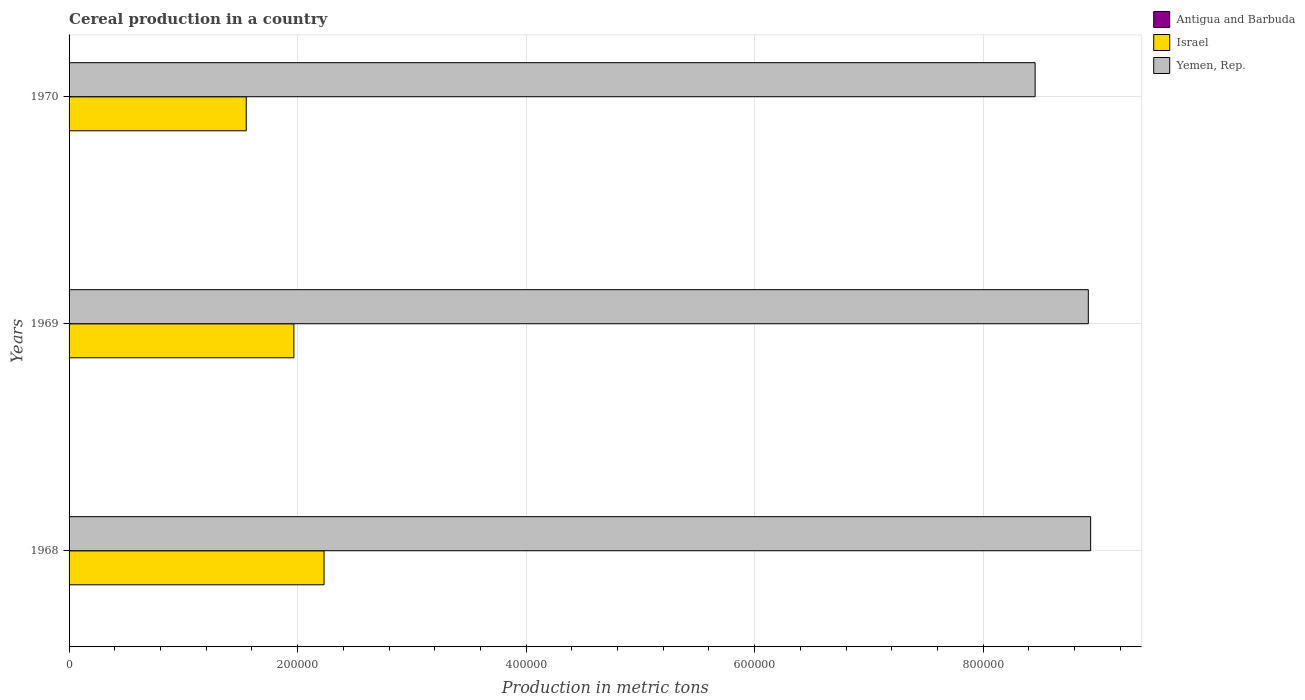How many different coloured bars are there?
Your response must be concise. 3. Are the number of bars on each tick of the Y-axis equal?
Your answer should be very brief. Yes. What is the label of the 3rd group of bars from the top?
Offer a very short reply. 1968. In how many cases, is the number of bars for a given year not equal to the number of legend labels?
Give a very brief answer. 0. What is the total cereal production in Antigua and Barbuda in 1970?
Ensure brevity in your answer.  60. Across all years, what is the maximum total cereal production in Yemen, Rep.?
Offer a very short reply. 8.94e+05. Across all years, what is the minimum total cereal production in Israel?
Offer a terse response. 1.55e+05. In which year was the total cereal production in Yemen, Rep. maximum?
Offer a very short reply. 1968. In which year was the total cereal production in Yemen, Rep. minimum?
Give a very brief answer. 1970. What is the total total cereal production in Antigua and Barbuda in the graph?
Ensure brevity in your answer.  135. What is the difference between the total cereal production in Yemen, Rep. in 1968 and that in 1970?
Offer a terse response. 4.86e+04. What is the difference between the total cereal production in Antigua and Barbuda in 1969 and the total cereal production in Israel in 1968?
Your response must be concise. -2.23e+05. What is the average total cereal production in Yemen, Rep. per year?
Your answer should be very brief. 8.77e+05. In the year 1969, what is the difference between the total cereal production in Yemen, Rep. and total cereal production in Antigua and Barbuda?
Offer a very short reply. 8.92e+05. In how many years, is the total cereal production in Israel greater than 880000 metric tons?
Provide a short and direct response. 0. What is the ratio of the total cereal production in Antigua and Barbuda in 1968 to that in 1970?
Your response must be concise. 0.5. Is the total cereal production in Antigua and Barbuda in 1968 less than that in 1970?
Keep it short and to the point. Yes. Is the difference between the total cereal production in Yemen, Rep. in 1968 and 1969 greater than the difference between the total cereal production in Antigua and Barbuda in 1968 and 1969?
Keep it short and to the point. Yes. What is the difference between the highest and the second highest total cereal production in Yemen, Rep.?
Give a very brief answer. 2026. What is the difference between the highest and the lowest total cereal production in Israel?
Your response must be concise. 6.81e+04. In how many years, is the total cereal production in Israel greater than the average total cereal production in Israel taken over all years?
Make the answer very short. 2. Is the sum of the total cereal production in Yemen, Rep. in 1968 and 1970 greater than the maximum total cereal production in Israel across all years?
Provide a short and direct response. Yes. Are all the bars in the graph horizontal?
Provide a succinct answer. Yes. How many years are there in the graph?
Your answer should be very brief. 3. Are the values on the major ticks of X-axis written in scientific E-notation?
Make the answer very short. No. Does the graph contain grids?
Keep it short and to the point. Yes. Where does the legend appear in the graph?
Your response must be concise. Top right. How are the legend labels stacked?
Your answer should be compact. Vertical. What is the title of the graph?
Keep it short and to the point. Cereal production in a country. Does "East Asia (all income levels)" appear as one of the legend labels in the graph?
Ensure brevity in your answer.  No. What is the label or title of the X-axis?
Your answer should be compact. Production in metric tons. What is the Production in metric tons of Antigua and Barbuda in 1968?
Offer a terse response. 30. What is the Production in metric tons in Israel in 1968?
Your answer should be compact. 2.23e+05. What is the Production in metric tons of Yemen, Rep. in 1968?
Your answer should be compact. 8.94e+05. What is the Production in metric tons of Antigua and Barbuda in 1969?
Ensure brevity in your answer.  45. What is the Production in metric tons of Israel in 1969?
Your answer should be compact. 1.97e+05. What is the Production in metric tons in Yemen, Rep. in 1969?
Keep it short and to the point. 8.92e+05. What is the Production in metric tons of Israel in 1970?
Keep it short and to the point. 1.55e+05. What is the Production in metric tons of Yemen, Rep. in 1970?
Your answer should be very brief. 8.45e+05. Across all years, what is the maximum Production in metric tons of Antigua and Barbuda?
Provide a succinct answer. 60. Across all years, what is the maximum Production in metric tons of Israel?
Provide a short and direct response. 2.23e+05. Across all years, what is the maximum Production in metric tons of Yemen, Rep.?
Make the answer very short. 8.94e+05. Across all years, what is the minimum Production in metric tons of Antigua and Barbuda?
Offer a very short reply. 30. Across all years, what is the minimum Production in metric tons of Israel?
Make the answer very short. 1.55e+05. Across all years, what is the minimum Production in metric tons of Yemen, Rep.?
Your response must be concise. 8.45e+05. What is the total Production in metric tons of Antigua and Barbuda in the graph?
Provide a short and direct response. 135. What is the total Production in metric tons in Israel in the graph?
Your response must be concise. 5.75e+05. What is the total Production in metric tons of Yemen, Rep. in the graph?
Ensure brevity in your answer.  2.63e+06. What is the difference between the Production in metric tons in Israel in 1968 and that in 1969?
Provide a succinct answer. 2.64e+04. What is the difference between the Production in metric tons of Yemen, Rep. in 1968 and that in 1969?
Ensure brevity in your answer.  2026. What is the difference between the Production in metric tons in Antigua and Barbuda in 1968 and that in 1970?
Provide a short and direct response. -30. What is the difference between the Production in metric tons of Israel in 1968 and that in 1970?
Give a very brief answer. 6.81e+04. What is the difference between the Production in metric tons in Yemen, Rep. in 1968 and that in 1970?
Provide a succinct answer. 4.86e+04. What is the difference between the Production in metric tons in Israel in 1969 and that in 1970?
Provide a succinct answer. 4.17e+04. What is the difference between the Production in metric tons of Yemen, Rep. in 1969 and that in 1970?
Your response must be concise. 4.66e+04. What is the difference between the Production in metric tons of Antigua and Barbuda in 1968 and the Production in metric tons of Israel in 1969?
Provide a succinct answer. -1.97e+05. What is the difference between the Production in metric tons in Antigua and Barbuda in 1968 and the Production in metric tons in Yemen, Rep. in 1969?
Your answer should be very brief. -8.92e+05. What is the difference between the Production in metric tons in Israel in 1968 and the Production in metric tons in Yemen, Rep. in 1969?
Ensure brevity in your answer.  -6.69e+05. What is the difference between the Production in metric tons of Antigua and Barbuda in 1968 and the Production in metric tons of Israel in 1970?
Ensure brevity in your answer.  -1.55e+05. What is the difference between the Production in metric tons of Antigua and Barbuda in 1968 and the Production in metric tons of Yemen, Rep. in 1970?
Offer a terse response. -8.45e+05. What is the difference between the Production in metric tons of Israel in 1968 and the Production in metric tons of Yemen, Rep. in 1970?
Offer a very short reply. -6.22e+05. What is the difference between the Production in metric tons of Antigua and Barbuda in 1969 and the Production in metric tons of Israel in 1970?
Provide a short and direct response. -1.55e+05. What is the difference between the Production in metric tons in Antigua and Barbuda in 1969 and the Production in metric tons in Yemen, Rep. in 1970?
Give a very brief answer. -8.45e+05. What is the difference between the Production in metric tons of Israel in 1969 and the Production in metric tons of Yemen, Rep. in 1970?
Offer a very short reply. -6.49e+05. What is the average Production in metric tons of Antigua and Barbuda per year?
Your answer should be very brief. 45. What is the average Production in metric tons of Israel per year?
Provide a short and direct response. 1.92e+05. What is the average Production in metric tons of Yemen, Rep. per year?
Offer a very short reply. 8.77e+05. In the year 1968, what is the difference between the Production in metric tons of Antigua and Barbuda and Production in metric tons of Israel?
Make the answer very short. -2.23e+05. In the year 1968, what is the difference between the Production in metric tons in Antigua and Barbuda and Production in metric tons in Yemen, Rep.?
Give a very brief answer. -8.94e+05. In the year 1968, what is the difference between the Production in metric tons of Israel and Production in metric tons of Yemen, Rep.?
Ensure brevity in your answer.  -6.71e+05. In the year 1969, what is the difference between the Production in metric tons in Antigua and Barbuda and Production in metric tons in Israel?
Offer a very short reply. -1.97e+05. In the year 1969, what is the difference between the Production in metric tons in Antigua and Barbuda and Production in metric tons in Yemen, Rep.?
Your response must be concise. -8.92e+05. In the year 1969, what is the difference between the Production in metric tons in Israel and Production in metric tons in Yemen, Rep.?
Keep it short and to the point. -6.95e+05. In the year 1970, what is the difference between the Production in metric tons in Antigua and Barbuda and Production in metric tons in Israel?
Give a very brief answer. -1.55e+05. In the year 1970, what is the difference between the Production in metric tons of Antigua and Barbuda and Production in metric tons of Yemen, Rep.?
Your answer should be very brief. -8.45e+05. In the year 1970, what is the difference between the Production in metric tons of Israel and Production in metric tons of Yemen, Rep.?
Give a very brief answer. -6.90e+05. What is the ratio of the Production in metric tons of Israel in 1968 to that in 1969?
Your answer should be compact. 1.13. What is the ratio of the Production in metric tons in Israel in 1968 to that in 1970?
Keep it short and to the point. 1.44. What is the ratio of the Production in metric tons in Yemen, Rep. in 1968 to that in 1970?
Offer a terse response. 1.06. What is the ratio of the Production in metric tons of Antigua and Barbuda in 1969 to that in 1970?
Provide a succinct answer. 0.75. What is the ratio of the Production in metric tons in Israel in 1969 to that in 1970?
Your response must be concise. 1.27. What is the ratio of the Production in metric tons of Yemen, Rep. in 1969 to that in 1970?
Offer a terse response. 1.06. What is the difference between the highest and the second highest Production in metric tons of Israel?
Keep it short and to the point. 2.64e+04. What is the difference between the highest and the second highest Production in metric tons in Yemen, Rep.?
Your answer should be very brief. 2026. What is the difference between the highest and the lowest Production in metric tons in Israel?
Give a very brief answer. 6.81e+04. What is the difference between the highest and the lowest Production in metric tons in Yemen, Rep.?
Give a very brief answer. 4.86e+04. 